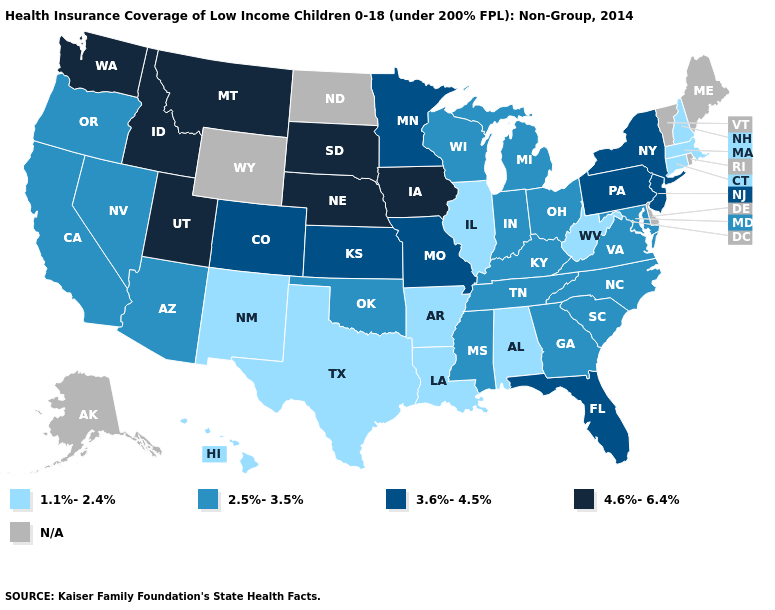What is the value of West Virginia?
Give a very brief answer. 1.1%-2.4%. What is the value of Maryland?
Short answer required. 2.5%-3.5%. Name the states that have a value in the range 4.6%-6.4%?
Quick response, please. Idaho, Iowa, Montana, Nebraska, South Dakota, Utah, Washington. How many symbols are there in the legend?
Quick response, please. 5. What is the lowest value in the MidWest?
Answer briefly. 1.1%-2.4%. Which states have the highest value in the USA?
Write a very short answer. Idaho, Iowa, Montana, Nebraska, South Dakota, Utah, Washington. Does Utah have the highest value in the West?
Write a very short answer. Yes. Name the states that have a value in the range 4.6%-6.4%?
Be succinct. Idaho, Iowa, Montana, Nebraska, South Dakota, Utah, Washington. What is the lowest value in the West?
Write a very short answer. 1.1%-2.4%. What is the highest value in the West ?
Give a very brief answer. 4.6%-6.4%. Does the first symbol in the legend represent the smallest category?
Be succinct. Yes. What is the value of Texas?
Concise answer only. 1.1%-2.4%. Which states hav the highest value in the West?
Answer briefly. Idaho, Montana, Utah, Washington. Which states have the lowest value in the USA?
Concise answer only. Alabama, Arkansas, Connecticut, Hawaii, Illinois, Louisiana, Massachusetts, New Hampshire, New Mexico, Texas, West Virginia. 